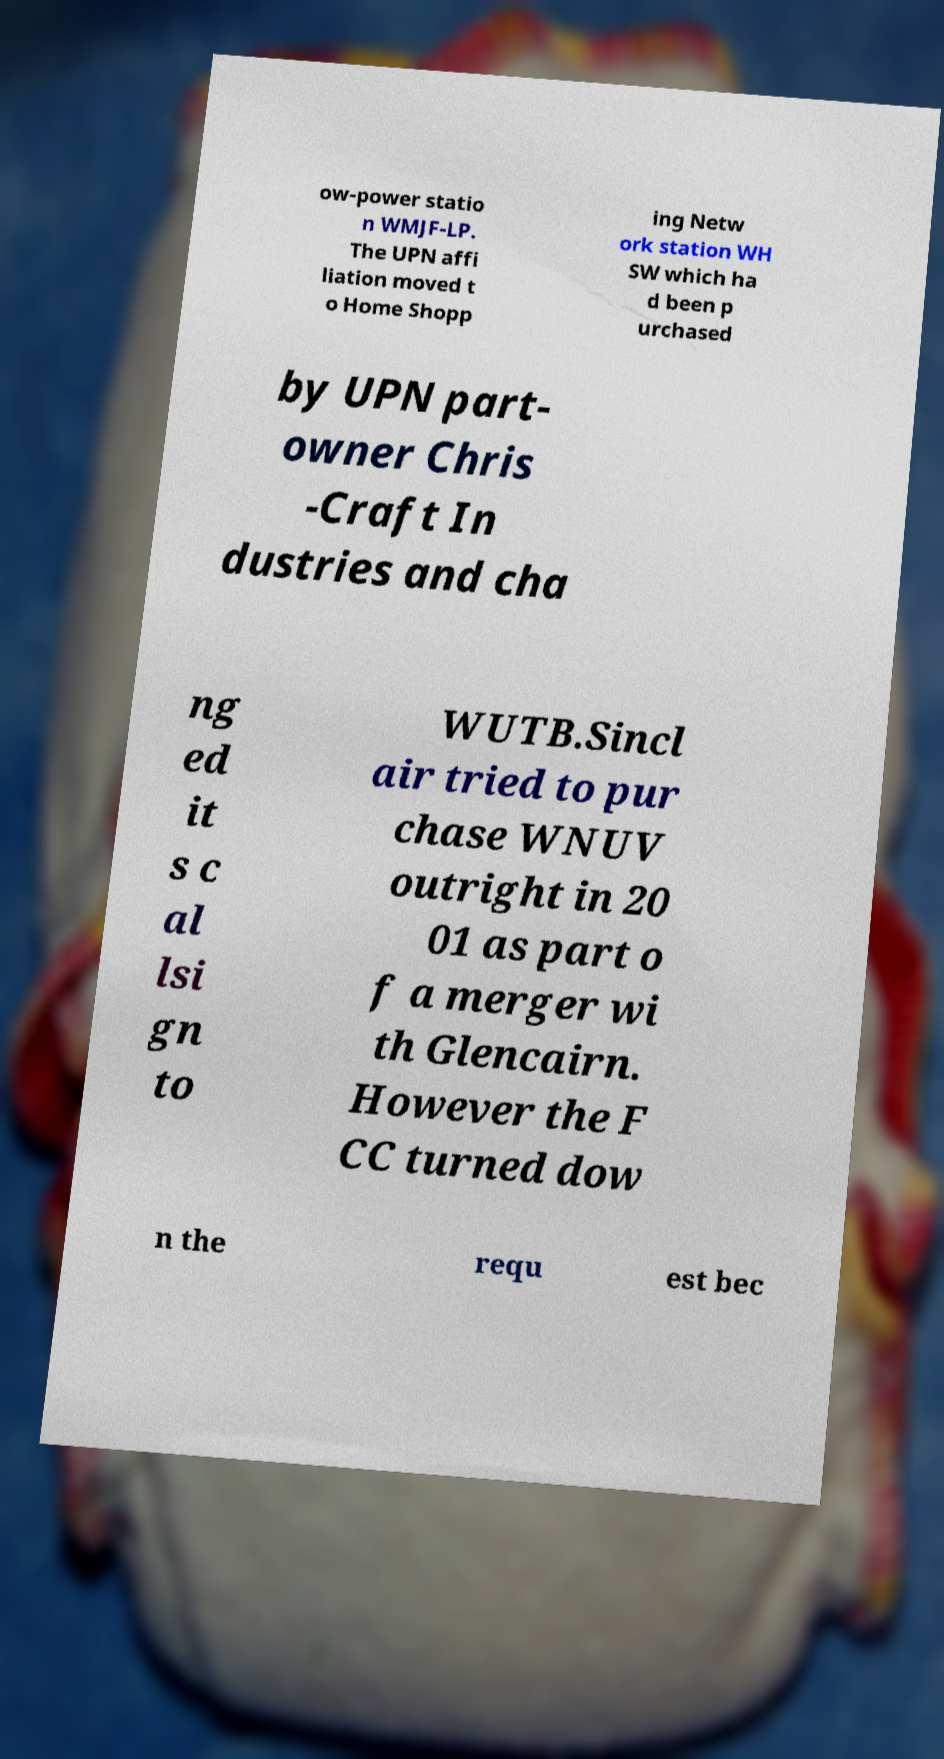Could you assist in decoding the text presented in this image and type it out clearly? ow-power statio n WMJF-LP. The UPN affi liation moved t o Home Shopp ing Netw ork station WH SW which ha d been p urchased by UPN part- owner Chris -Craft In dustries and cha ng ed it s c al lsi gn to WUTB.Sincl air tried to pur chase WNUV outright in 20 01 as part o f a merger wi th Glencairn. However the F CC turned dow n the requ est bec 